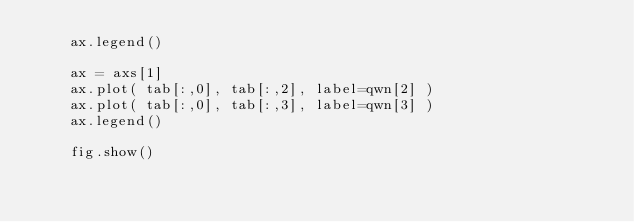<code> <loc_0><loc_0><loc_500><loc_500><_Python_>    ax.legend()

    ax = axs[1]
    ax.plot( tab[:,0], tab[:,2], label=qwn[2] )
    ax.plot( tab[:,0], tab[:,3], label=qwn[3] )
    ax.legend()

    fig.show()

</code> 